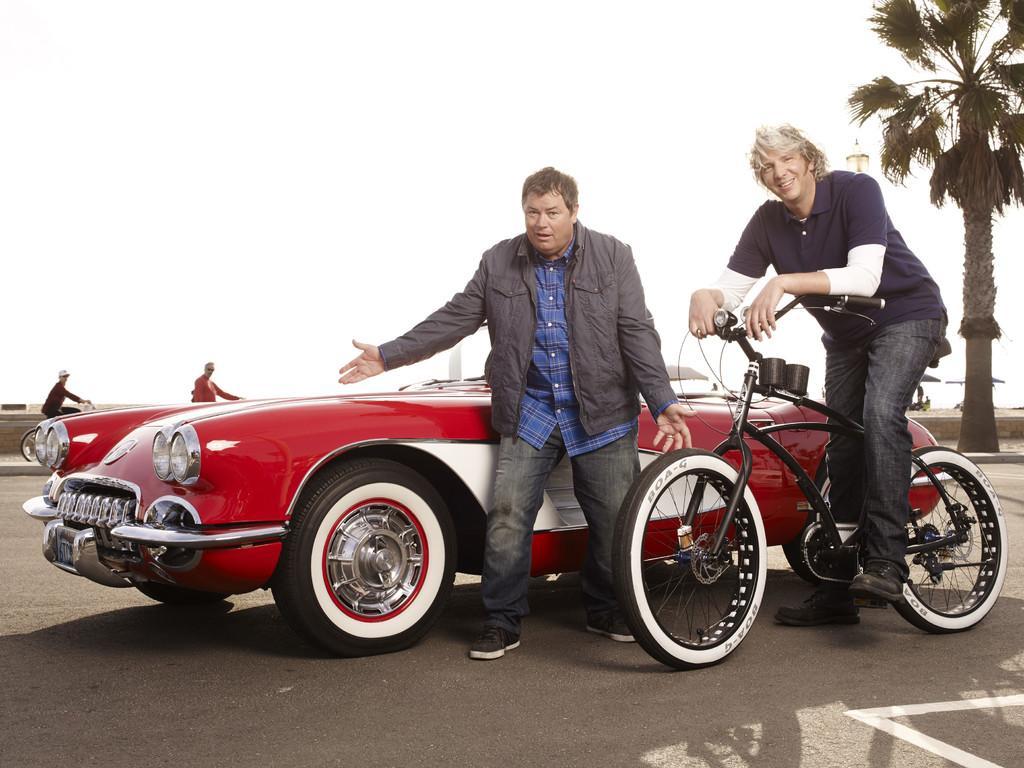Could you give a brief overview of what you see in this image? This person standing. This person sitting and holding bicycle. we can see car on the road. On the background we can see sky,tree,persons. 